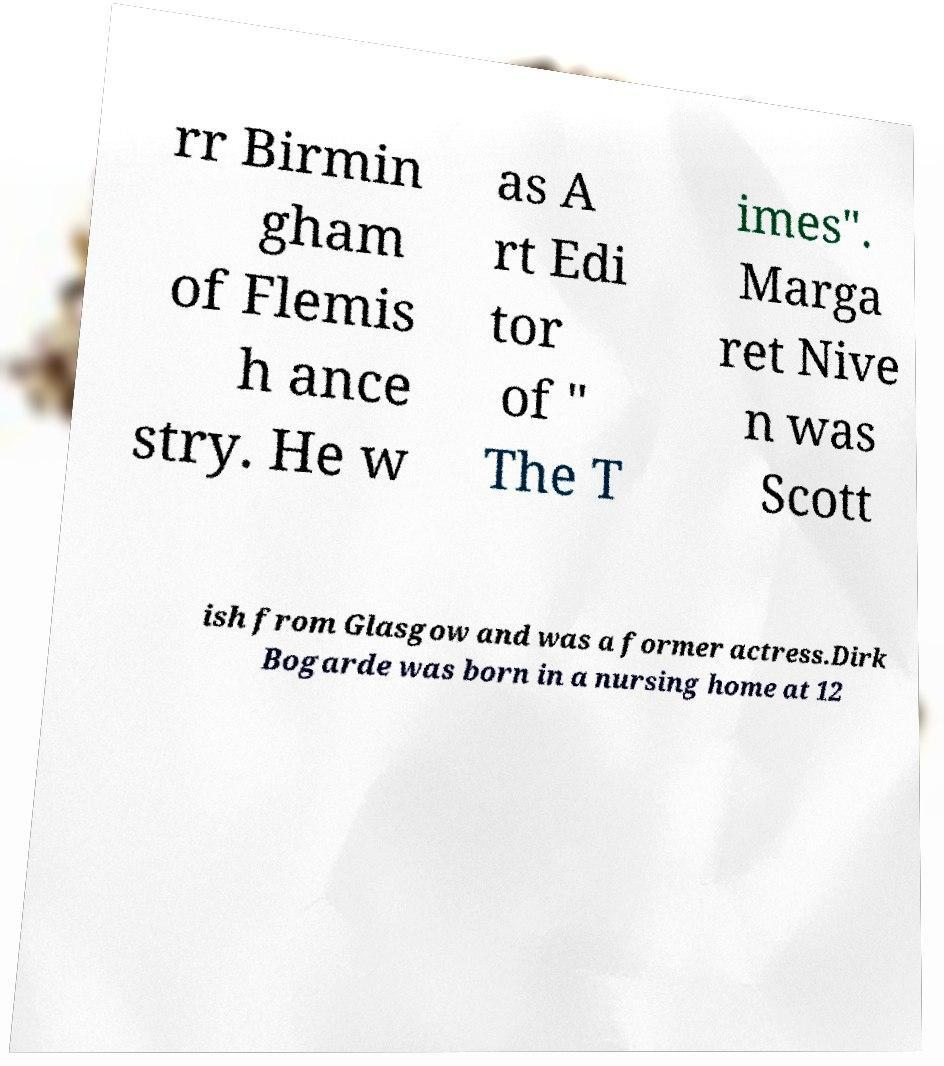Please identify and transcribe the text found in this image. rr Birmin gham of Flemis h ance stry. He w as A rt Edi tor of " The T imes". Marga ret Nive n was Scott ish from Glasgow and was a former actress.Dirk Bogarde was born in a nursing home at 12 